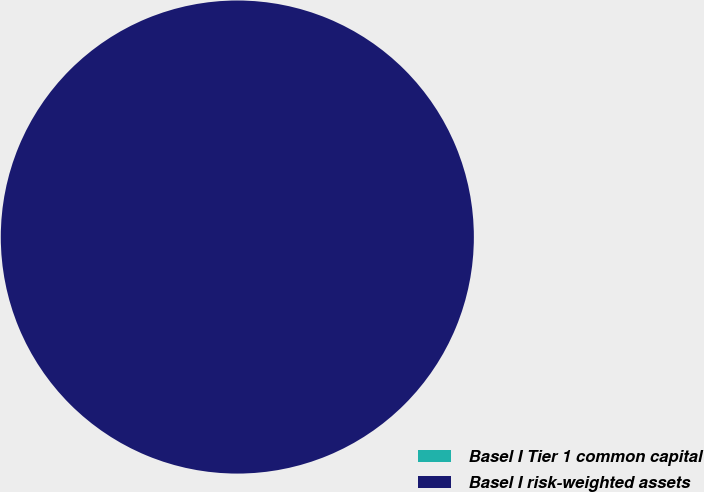Convert chart to OTSL. <chart><loc_0><loc_0><loc_500><loc_500><pie_chart><fcel>Basel I Tier 1 common capital<fcel>Basel I risk-weighted assets<nl><fcel>0.0%<fcel>100.0%<nl></chart> 